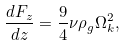Convert formula to latex. <formula><loc_0><loc_0><loc_500><loc_500>\frac { d F _ { z } } { d z } = \frac { 9 } { 4 } \nu \rho _ { g } \Omega _ { k } ^ { 2 } ,</formula> 